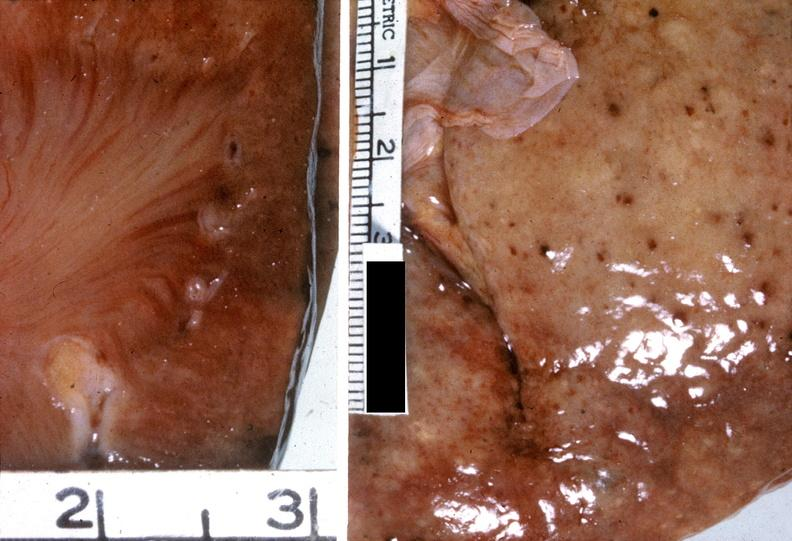does this image show kidney, malignant hypertension?
Answer the question using a single word or phrase. Yes 